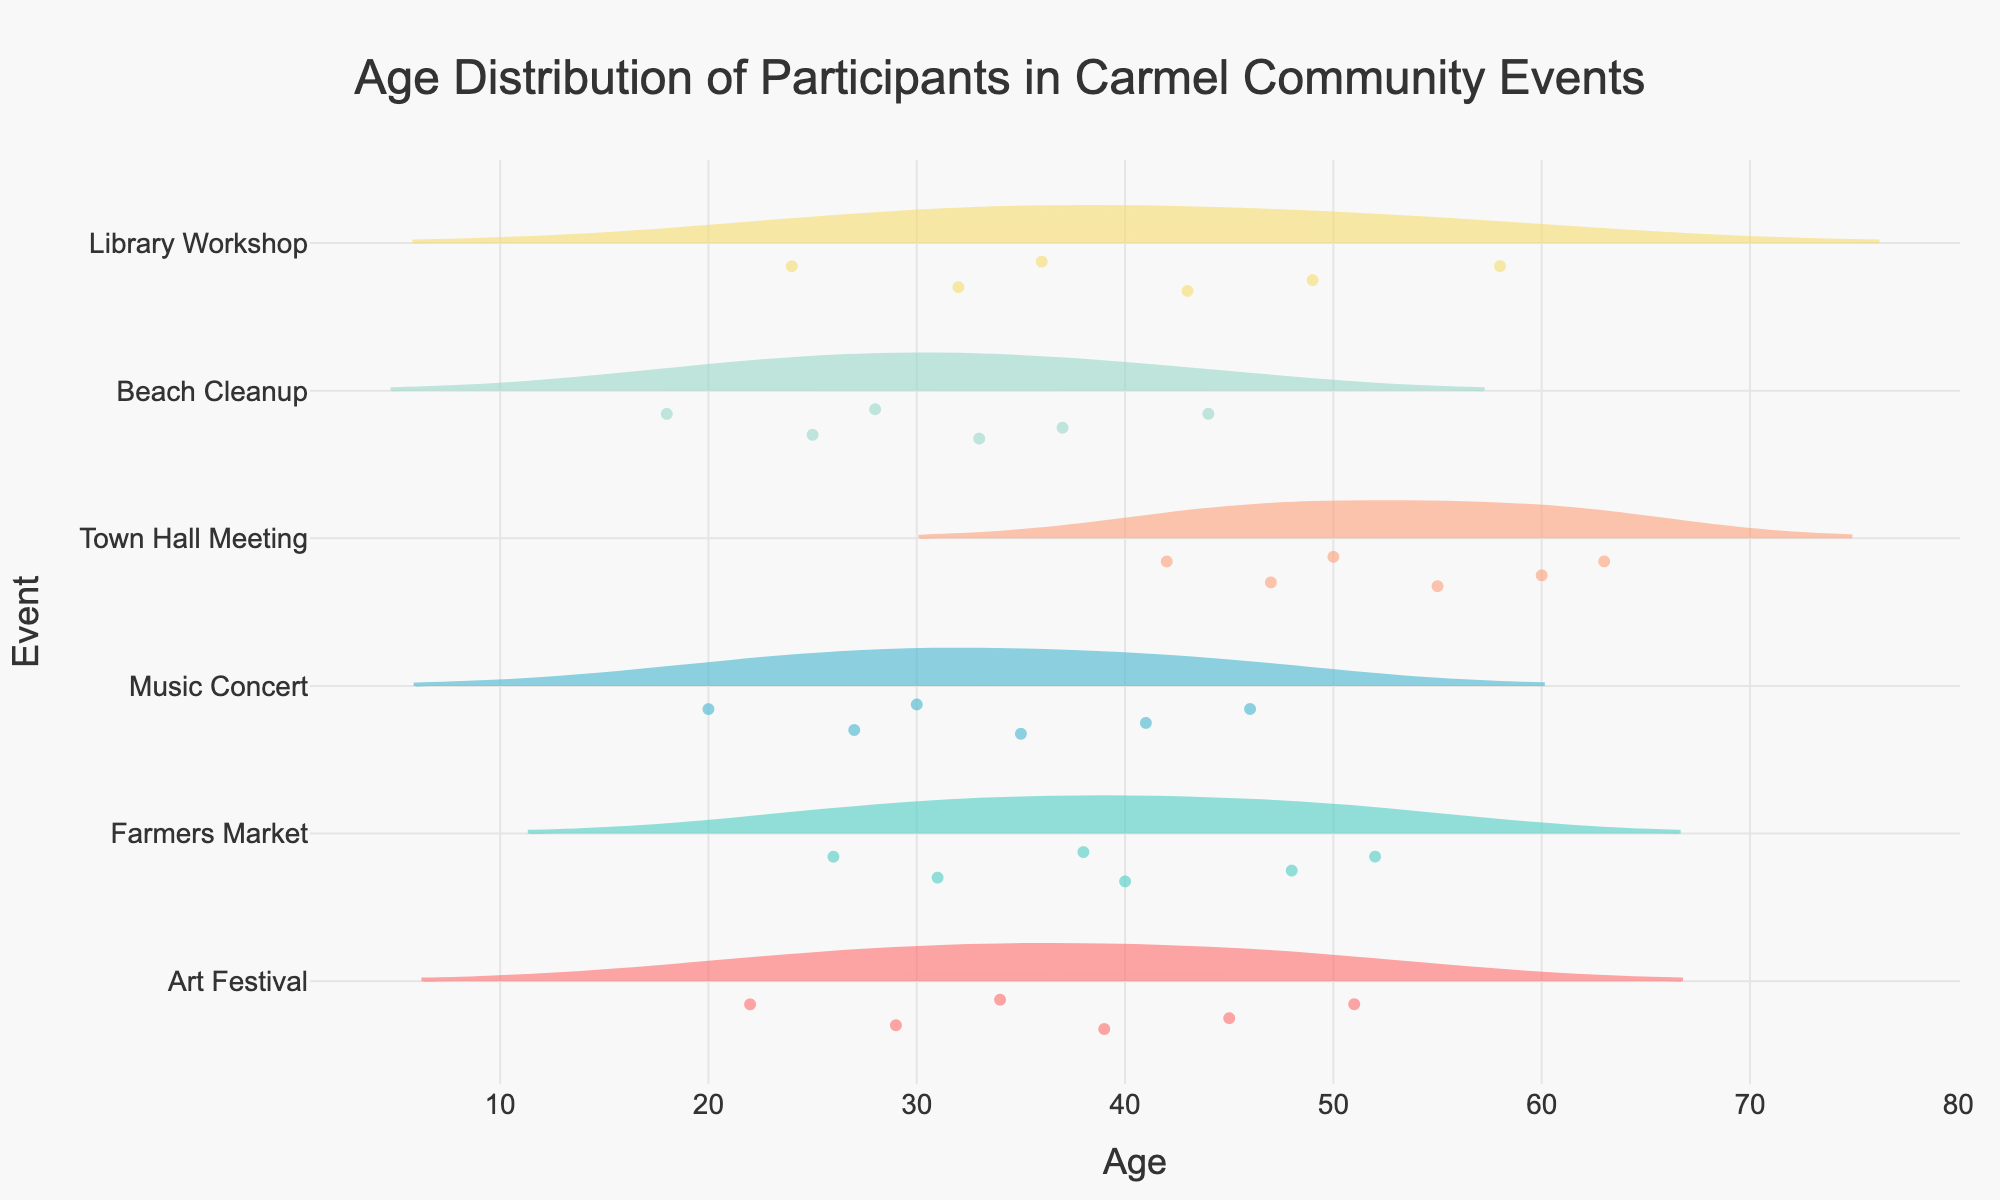What's the title of the chart? The title is usually located at the top of the chart. In this case, the title is centered and reads "Age Distribution of Participants in Carmel Community Events". This information helps to know what the chart represents.
Answer: Age Distribution of Participants in Carmel Community Events What does the horizontal axis represent? The horizontal axis typically represents a variable in the data. In the provided figure, the x-axis represents the "Age" of the participants in the community events.
Answer: Age Which event has the widest age range of participants? To find the event with the widest age range, look at the horizontal length of the violin plots for each event. The "Town Hall Meeting" has participants aged 42 to 63, which is a range of 21 years.
Answer: Town Hall Meeting What's the median age of participants in the Beach Cleanup event? In a violin plot, the median is often represented by a horizontal line within the plot. For "Beach Cleanup", the median is the horizontal line around age 33.
Answer: 33 Which event has the youngest participant? By observing the lowest point in the x-axis across all events, the youngest participant is found in the "Beach Cleanup" event, aged 18.
Answer: Beach Cleanup How does the participant age distribution for the Music Concert compare to the Farmers Market? To compare, look at the violin plots for both events. Music Concert participants range from approximately 20 to 46 years, while Farmers Market participants range from approximately 26 to 52 years. Farmers Market has a slightly older participant range.
Answer: Farmers Market generally has older participants than Music Concert Which event has the most concentrated age group? The most concentrated age group can be detected by looking at the density (width) of the violin plots. "Library Workshop" shows most participants clustering around the median age of 36.
Answer: Library Workshop What's the average age of participants in the Art Festival? To find the average, look at the density distribution within the violin plot and the mean line if available. The average appears to be around 36, given the spread and concentration of participants.
Answer: 36 Are there more young or older participants at the Town Hall Meeting? By noticing the spread and density of the violin plot for "Town Hall Meeting", it is clear that there are more older participants (above age 50) compared to younger participants (below age 50).
Answer: More older participants What's the age range where most events overlap? To find overlapping age ranges, look for regions where multiple violin plots coincide in the x-axis. Most events overlap in the age range of approximately 30 to 40 years.
Answer: 30 to 40 years 